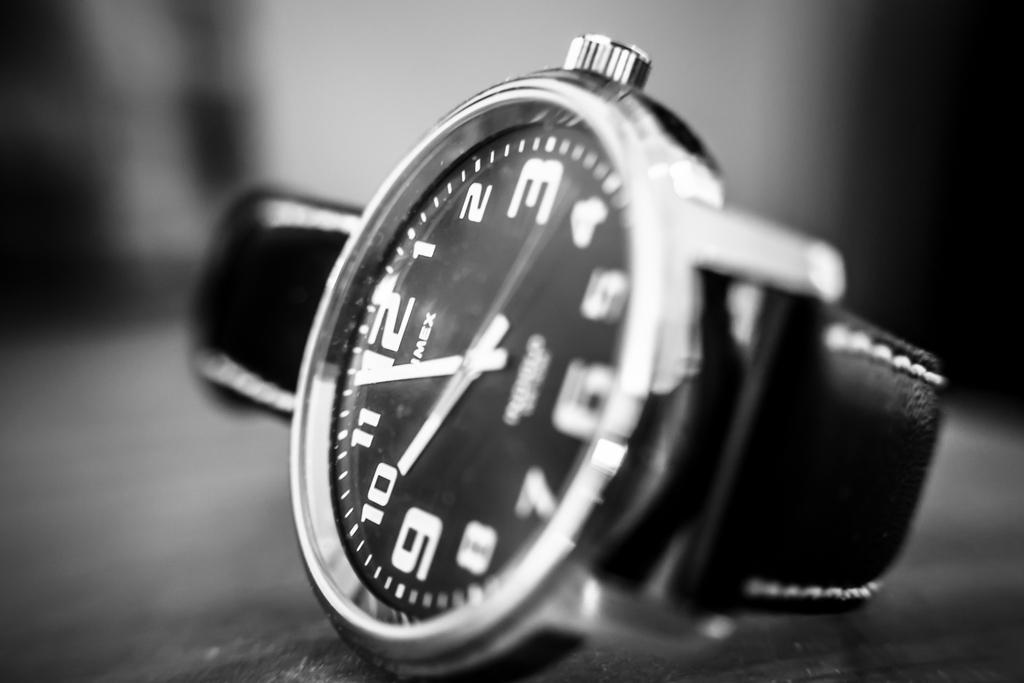Can you describe this image briefly? It is a black and white picture. In the center of the image we can see one watch. In the background, we can see it is blurred. 